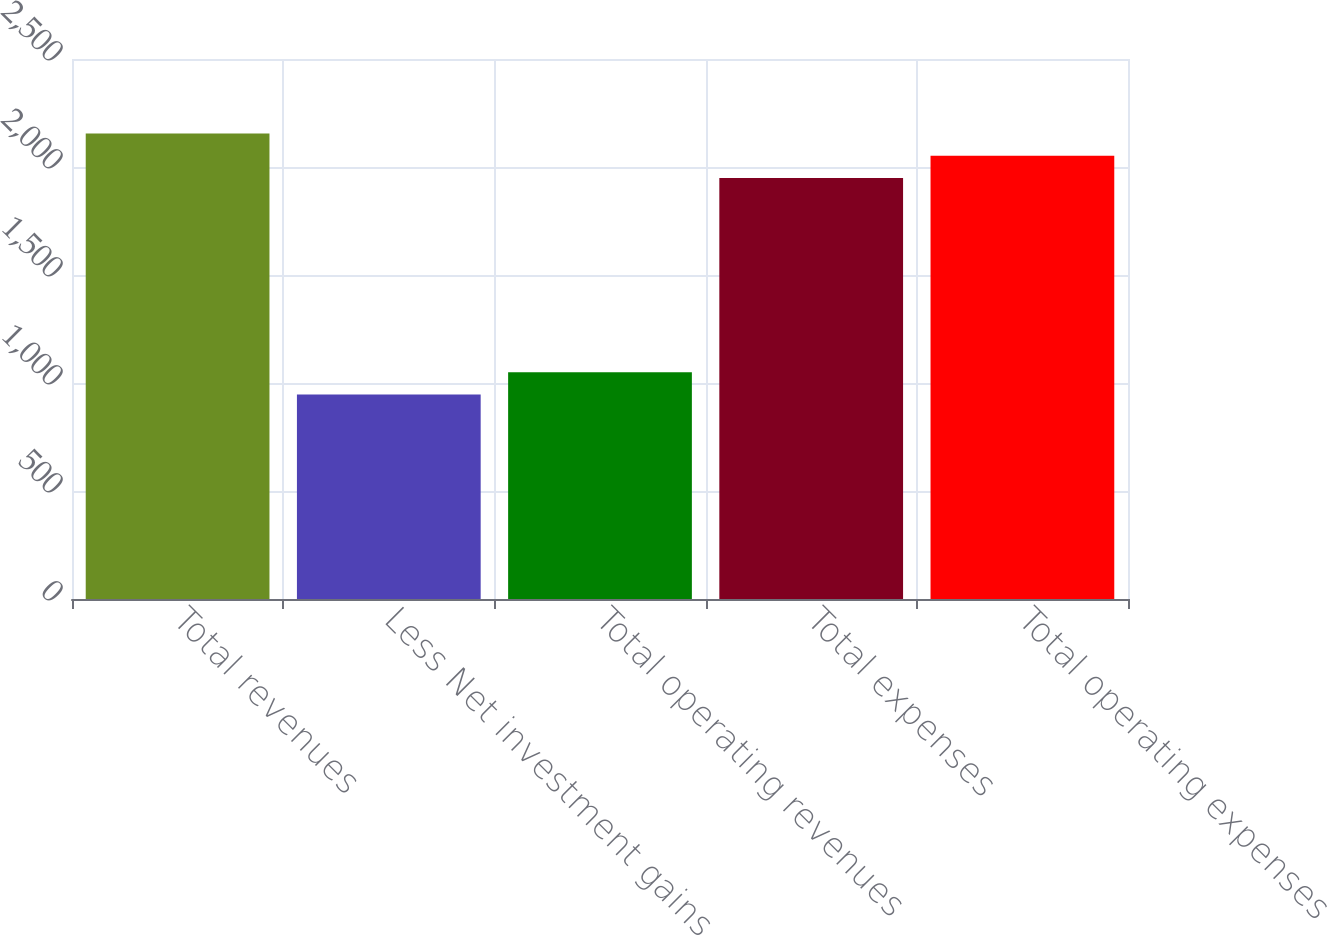Convert chart. <chart><loc_0><loc_0><loc_500><loc_500><bar_chart><fcel>Total revenues<fcel>Less Net investment gains<fcel>Total operating revenues<fcel>Total expenses<fcel>Total operating expenses<nl><fcel>2155.4<fcel>947<fcel>1050.2<fcel>1949<fcel>2052.2<nl></chart> 